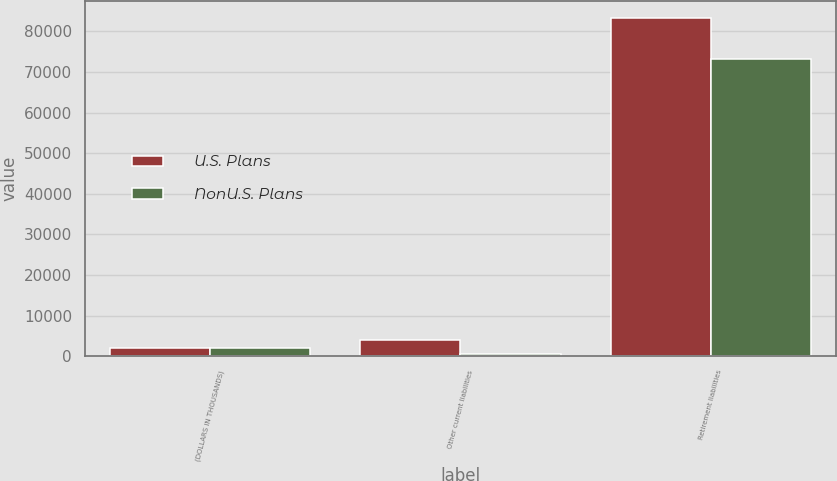Convert chart to OTSL. <chart><loc_0><loc_0><loc_500><loc_500><stacked_bar_chart><ecel><fcel>(DOLLARS IN THOUSANDS)<fcel>Other current liabilities<fcel>Retirement liabilities<nl><fcel>U.S. Plans<fcel>2015<fcel>3866<fcel>83334<nl><fcel>NonU.S. Plans<fcel>2015<fcel>613<fcel>73109<nl></chart> 